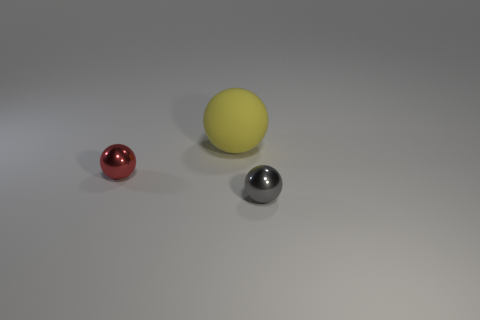How many spheres are there in total? There are three spheres in total in the image. 